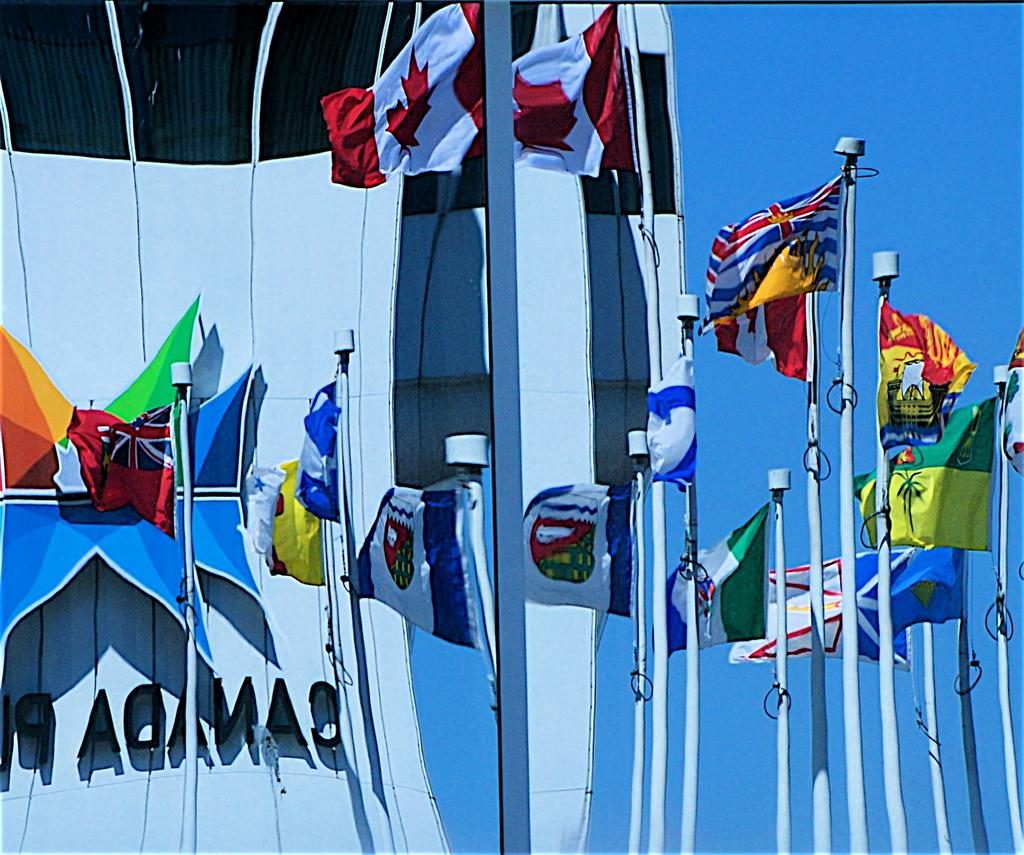What is the main structure visible in the image? There is a building in the image. Are there any additional features near the building? Yes, there are flag posts in front of the building. What type of pie is being served at the cemetery in the image? There is no cemetery or pie present in the image; it only features a building and flag posts. 